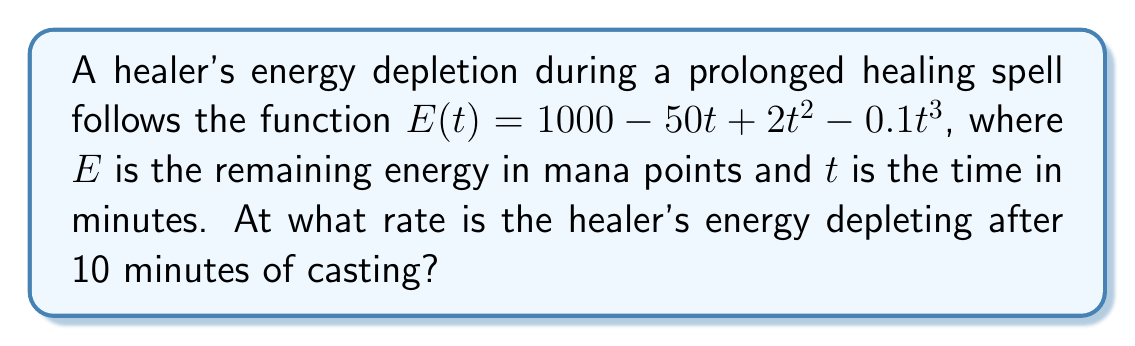What is the answer to this math problem? To find the rate of energy depletion at a specific time, we need to find the derivative of the energy function and evaluate it at the given time.

1. The energy function is:
   $E(t) = 1000 - 50t + 2t^2 - 0.1t^3$

2. Take the derivative of $E(t)$ with respect to $t$:
   $$\frac{dE}{dt} = -50 + 4t - 0.3t^2$$

3. This derivative represents the instantaneous rate of change of energy with respect to time.

4. To find the rate of energy depletion at $t = 10$ minutes, substitute $t = 10$ into the derivative:
   $$\frac{dE}{dt}\bigg|_{t=10} = -50 + 4(10) - 0.3(10)^2$$
   $$= -50 + 40 - 30$$
   $$= -40$$

5. The negative sign indicates that energy is decreasing (depleting).

Therefore, after 10 minutes of casting, the healer's energy is depleting at a rate of 40 mana points per minute.
Answer: -40 mana points per minute 